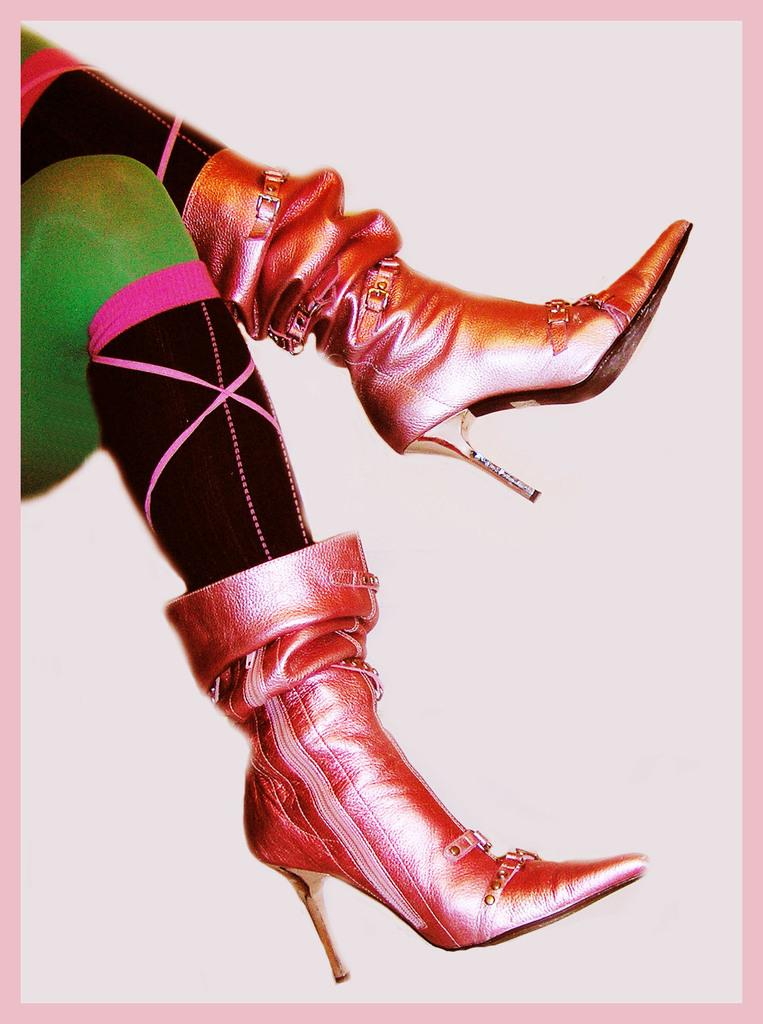What body parts are visible in the image? Two legs and two heels are visible in the image. What can be inferred about the person's footwear based on the visible heels? The person is likely wearing shoes or high heels. What is the color of the background in the image? The background of the image is colored. What type of nerve can be seen in the image? There is no nerve visible in the image; only legs and heels are present. Can you tell me the name of the judge in the image? There is no judge present in the image; it features legs and heels. 